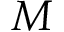Convert formula to latex. <formula><loc_0><loc_0><loc_500><loc_500>M</formula> 